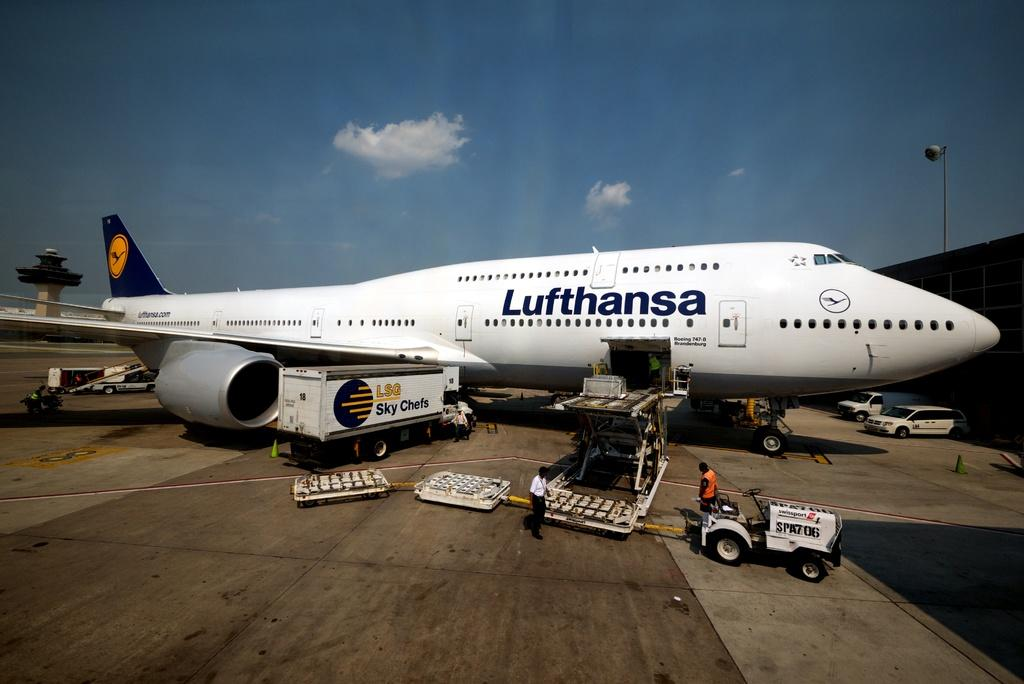<image>
Offer a succinct explanation of the picture presented. lufthansa jet being loaded by lsg sky chefs and baggage handlers 